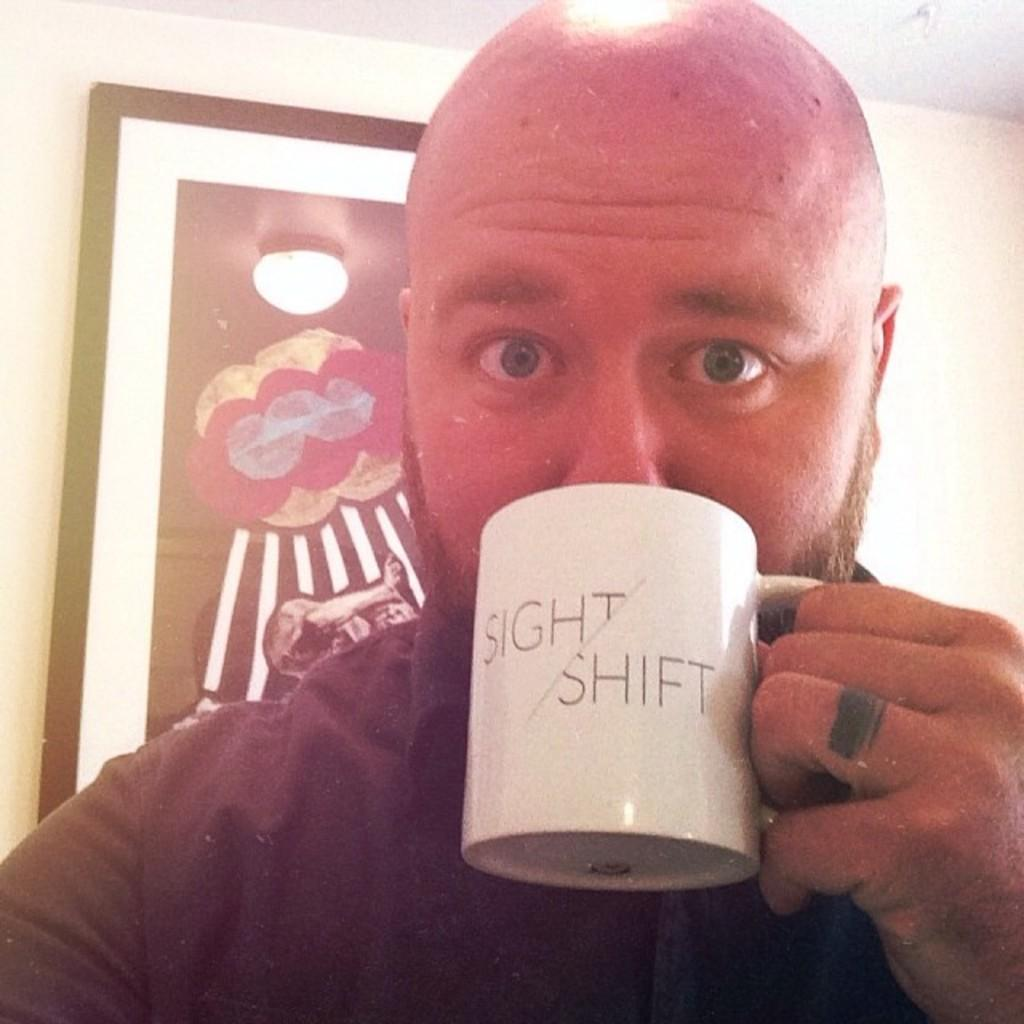<image>
Present a compact description of the photo's key features. A man is drinking out of a mug that says sight shift. 